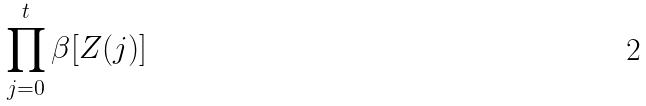Convert formula to latex. <formula><loc_0><loc_0><loc_500><loc_500>\prod _ { j = 0 } ^ { t } \beta [ Z ( j ) ]</formula> 